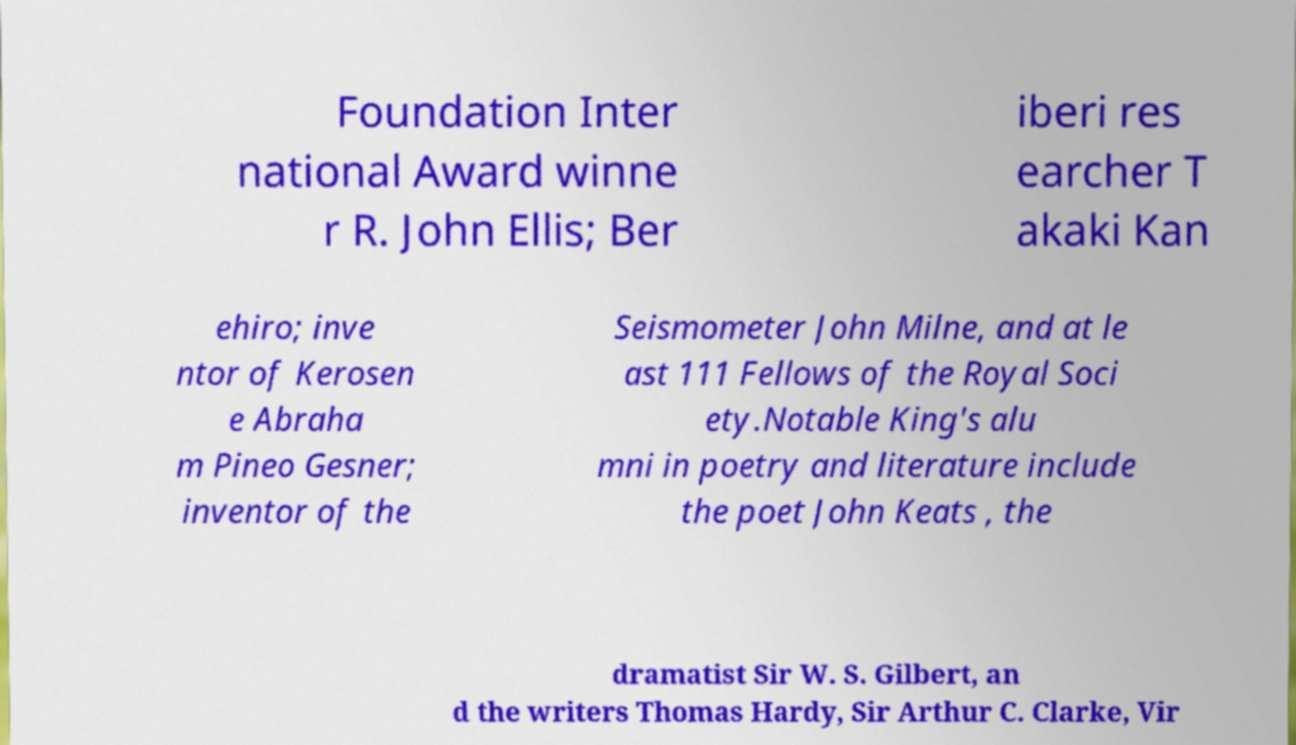Can you accurately transcribe the text from the provided image for me? Foundation Inter national Award winne r R. John Ellis; Ber iberi res earcher T akaki Kan ehiro; inve ntor of Kerosen e Abraha m Pineo Gesner; inventor of the Seismometer John Milne, and at le ast 111 Fellows of the Royal Soci ety.Notable King's alu mni in poetry and literature include the poet John Keats , the dramatist Sir W. S. Gilbert, an d the writers Thomas Hardy, Sir Arthur C. Clarke, Vir 